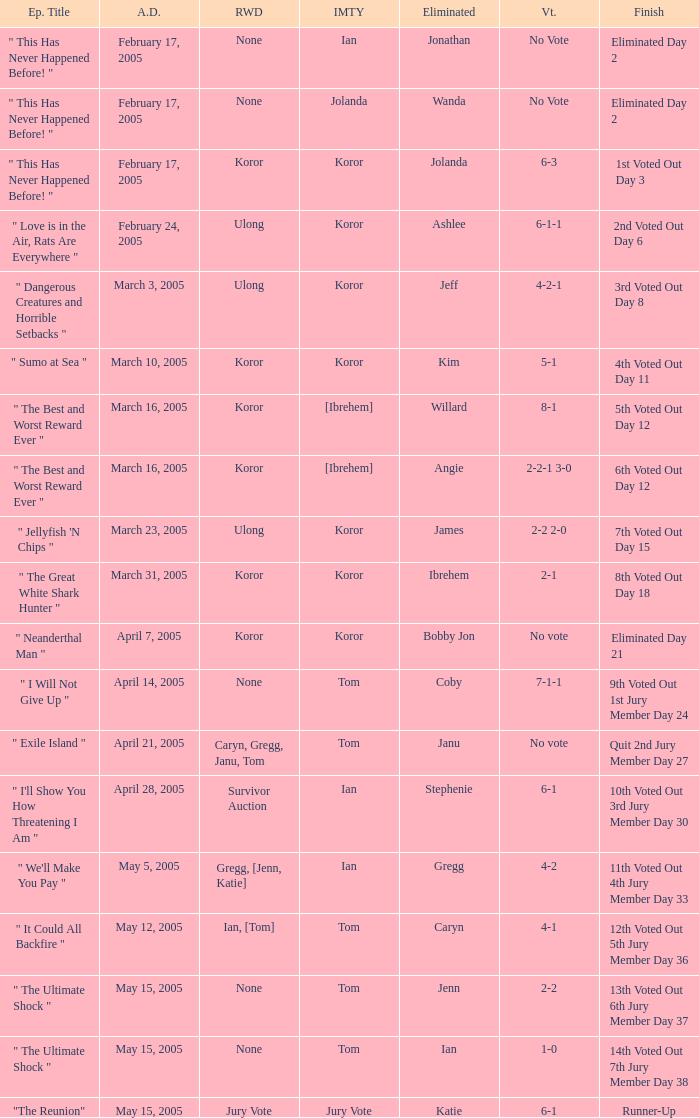I'm looking to parse the entire table for insights. Could you assist me with that? {'header': ['Ep. Title', 'A.D.', 'RWD', 'IMTY', 'Eliminated', 'Vt.', 'Finish'], 'rows': [['" This Has Never Happened Before! "', 'February 17, 2005', 'None', 'Ian', 'Jonathan', 'No Vote', 'Eliminated Day 2'], ['" This Has Never Happened Before! "', 'February 17, 2005', 'None', 'Jolanda', 'Wanda', 'No Vote', 'Eliminated Day 2'], ['" This Has Never Happened Before! "', 'February 17, 2005', 'Koror', 'Koror', 'Jolanda', '6-3', '1st Voted Out Day 3'], ['" Love is in the Air, Rats Are Everywhere "', 'February 24, 2005', 'Ulong', 'Koror', 'Ashlee', '6-1-1', '2nd Voted Out Day 6'], ['" Dangerous Creatures and Horrible Setbacks "', 'March 3, 2005', 'Ulong', 'Koror', 'Jeff', '4-2-1', '3rd Voted Out Day 8'], ['" Sumo at Sea "', 'March 10, 2005', 'Koror', 'Koror', 'Kim', '5-1', '4th Voted Out Day 11'], ['" The Best and Worst Reward Ever "', 'March 16, 2005', 'Koror', '[Ibrehem]', 'Willard', '8-1', '5th Voted Out Day 12'], ['" The Best and Worst Reward Ever "', 'March 16, 2005', 'Koror', '[Ibrehem]', 'Angie', '2-2-1 3-0', '6th Voted Out Day 12'], ['" Jellyfish \'N Chips "', 'March 23, 2005', 'Ulong', 'Koror', 'James', '2-2 2-0', '7th Voted Out Day 15'], ['" The Great White Shark Hunter "', 'March 31, 2005', 'Koror', 'Koror', 'Ibrehem', '2-1', '8th Voted Out Day 18'], ['" Neanderthal Man "', 'April 7, 2005', 'Koror', 'Koror', 'Bobby Jon', 'No vote', 'Eliminated Day 21'], ['" I Will Not Give Up "', 'April 14, 2005', 'None', 'Tom', 'Coby', '7-1-1', '9th Voted Out 1st Jury Member Day 24'], ['" Exile Island "', 'April 21, 2005', 'Caryn, Gregg, Janu, Tom', 'Tom', 'Janu', 'No vote', 'Quit 2nd Jury Member Day 27'], ['" I\'ll Show You How Threatening I Am "', 'April 28, 2005', 'Survivor Auction', 'Ian', 'Stephenie', '6-1', '10th Voted Out 3rd Jury Member Day 30'], ['" We\'ll Make You Pay "', 'May 5, 2005', 'Gregg, [Jenn, Katie]', 'Ian', 'Gregg', '4-2', '11th Voted Out 4th Jury Member Day 33'], ['" It Could All Backfire "', 'May 12, 2005', 'Ian, [Tom]', 'Tom', 'Caryn', '4-1', '12th Voted Out 5th Jury Member Day 36'], ['" The Ultimate Shock "', 'May 15, 2005', 'None', 'Tom', 'Jenn', '2-2', '13th Voted Out 6th Jury Member Day 37'], ['" The Ultimate Shock "', 'May 15, 2005', 'None', 'Tom', 'Ian', '1-0', '14th Voted Out 7th Jury Member Day 38'], ['"The Reunion"', 'May 15, 2005', 'Jury Vote', 'Jury Vote', 'Katie', '6-1', 'Runner-Up']]} How many votes were taken when the outcome was "6th voted out day 12"? 1.0. 